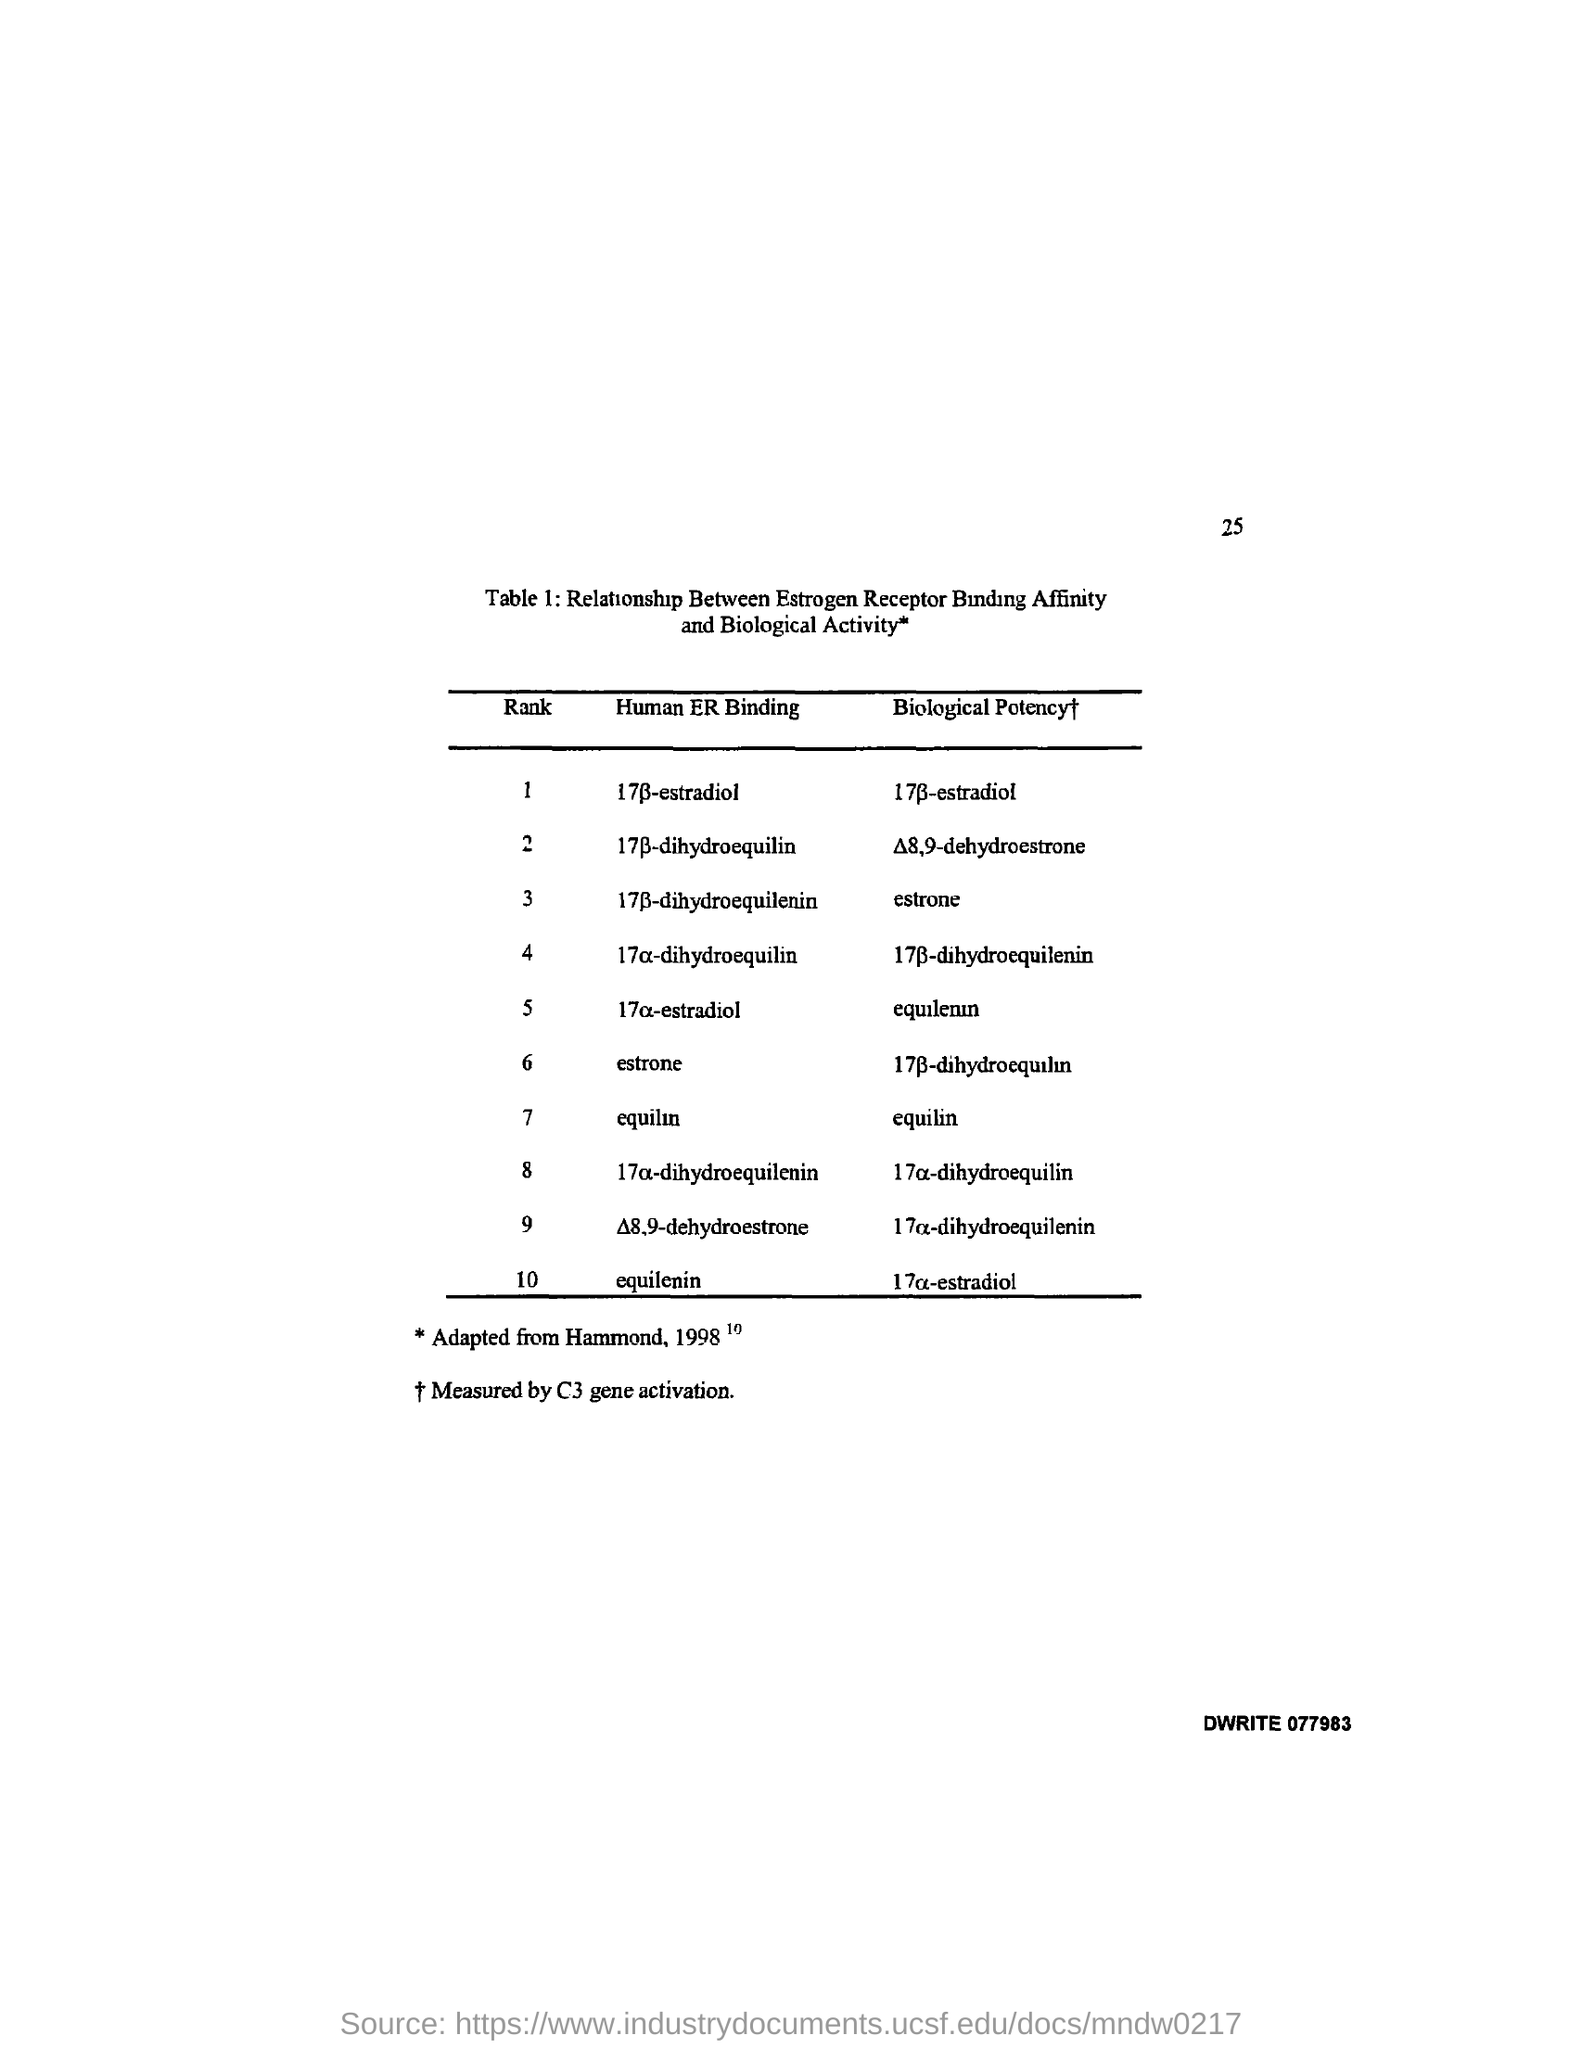Draw attention to some important aspects in this diagram. The biological potency of equilin is...equilin. The question "What is the page number on this document? 25..." asks for information about a document's page number. 